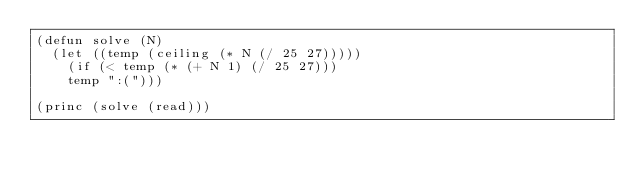Convert code to text. <code><loc_0><loc_0><loc_500><loc_500><_Lisp_>(defun solve (N)
  (let ((temp (ceiling (* N (/ 25 27)))))
    (if (< temp (* (+ N 1) (/ 25 27)))
	temp ":(")))

(princ (solve (read)))</code> 